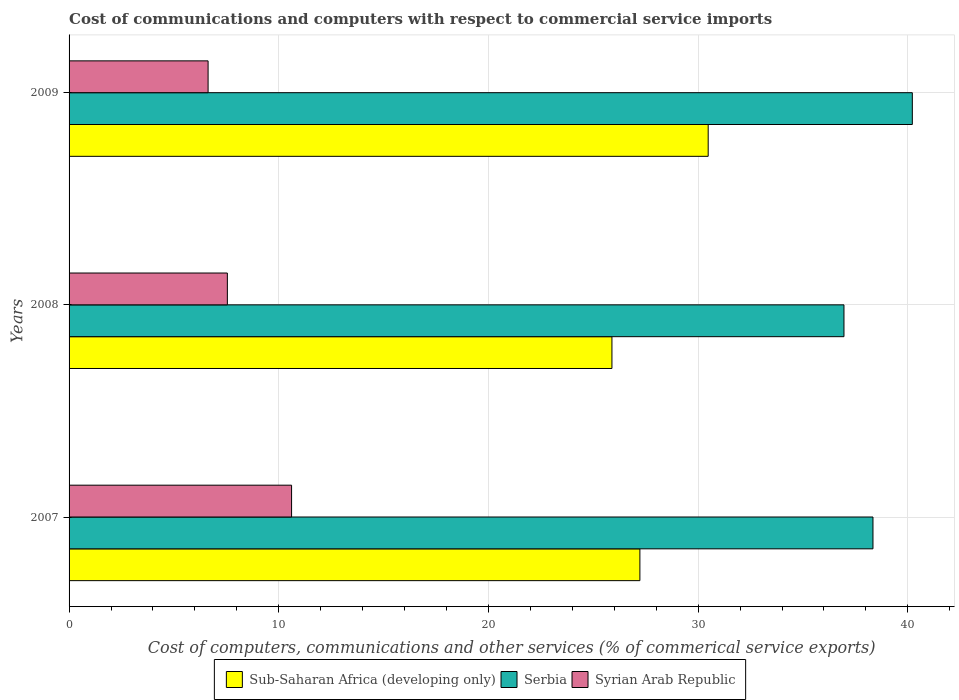How many groups of bars are there?
Provide a succinct answer. 3. How many bars are there on the 1st tick from the top?
Offer a very short reply. 3. How many bars are there on the 3rd tick from the bottom?
Give a very brief answer. 3. In how many cases, is the number of bars for a given year not equal to the number of legend labels?
Offer a terse response. 0. What is the cost of communications and computers in Serbia in 2007?
Your response must be concise. 38.34. Across all years, what is the maximum cost of communications and computers in Syrian Arab Republic?
Make the answer very short. 10.61. Across all years, what is the minimum cost of communications and computers in Serbia?
Offer a terse response. 36.95. In which year was the cost of communications and computers in Sub-Saharan Africa (developing only) maximum?
Your answer should be very brief. 2009. In which year was the cost of communications and computers in Serbia minimum?
Your answer should be very brief. 2008. What is the total cost of communications and computers in Sub-Saharan Africa (developing only) in the graph?
Give a very brief answer. 83.59. What is the difference between the cost of communications and computers in Serbia in 2007 and that in 2009?
Your answer should be very brief. -1.88. What is the difference between the cost of communications and computers in Serbia in 2008 and the cost of communications and computers in Syrian Arab Republic in 2007?
Ensure brevity in your answer.  26.34. What is the average cost of communications and computers in Serbia per year?
Ensure brevity in your answer.  38.5. In the year 2008, what is the difference between the cost of communications and computers in Sub-Saharan Africa (developing only) and cost of communications and computers in Syrian Arab Republic?
Offer a very short reply. 18.34. What is the ratio of the cost of communications and computers in Syrian Arab Republic in 2007 to that in 2008?
Your answer should be compact. 1.41. Is the cost of communications and computers in Syrian Arab Republic in 2007 less than that in 2009?
Give a very brief answer. No. Is the difference between the cost of communications and computers in Sub-Saharan Africa (developing only) in 2007 and 2009 greater than the difference between the cost of communications and computers in Syrian Arab Republic in 2007 and 2009?
Provide a short and direct response. No. What is the difference between the highest and the second highest cost of communications and computers in Syrian Arab Republic?
Give a very brief answer. 3.06. What is the difference between the highest and the lowest cost of communications and computers in Syrian Arab Republic?
Provide a succinct answer. 3.98. In how many years, is the cost of communications and computers in Sub-Saharan Africa (developing only) greater than the average cost of communications and computers in Sub-Saharan Africa (developing only) taken over all years?
Ensure brevity in your answer.  1. Is the sum of the cost of communications and computers in Serbia in 2007 and 2009 greater than the maximum cost of communications and computers in Syrian Arab Republic across all years?
Give a very brief answer. Yes. What does the 2nd bar from the top in 2007 represents?
Your answer should be compact. Serbia. What does the 2nd bar from the bottom in 2009 represents?
Your answer should be very brief. Serbia. Is it the case that in every year, the sum of the cost of communications and computers in Sub-Saharan Africa (developing only) and cost of communications and computers in Serbia is greater than the cost of communications and computers in Syrian Arab Republic?
Ensure brevity in your answer.  Yes. Are all the bars in the graph horizontal?
Offer a very short reply. Yes. How many years are there in the graph?
Provide a short and direct response. 3. What is the difference between two consecutive major ticks on the X-axis?
Provide a short and direct response. 10. Does the graph contain any zero values?
Offer a terse response. No. Where does the legend appear in the graph?
Your answer should be compact. Bottom center. What is the title of the graph?
Ensure brevity in your answer.  Cost of communications and computers with respect to commercial service imports. What is the label or title of the X-axis?
Offer a terse response. Cost of computers, communications and other services (% of commerical service exports). What is the Cost of computers, communications and other services (% of commerical service exports) in Sub-Saharan Africa (developing only) in 2007?
Offer a very short reply. 27.22. What is the Cost of computers, communications and other services (% of commerical service exports) of Serbia in 2007?
Offer a very short reply. 38.34. What is the Cost of computers, communications and other services (% of commerical service exports) in Syrian Arab Republic in 2007?
Provide a short and direct response. 10.61. What is the Cost of computers, communications and other services (% of commerical service exports) of Sub-Saharan Africa (developing only) in 2008?
Your response must be concise. 25.89. What is the Cost of computers, communications and other services (% of commerical service exports) of Serbia in 2008?
Make the answer very short. 36.95. What is the Cost of computers, communications and other services (% of commerical service exports) in Syrian Arab Republic in 2008?
Give a very brief answer. 7.55. What is the Cost of computers, communications and other services (% of commerical service exports) in Sub-Saharan Africa (developing only) in 2009?
Your answer should be compact. 30.48. What is the Cost of computers, communications and other services (% of commerical service exports) in Serbia in 2009?
Your response must be concise. 40.21. What is the Cost of computers, communications and other services (% of commerical service exports) in Syrian Arab Republic in 2009?
Make the answer very short. 6.63. Across all years, what is the maximum Cost of computers, communications and other services (% of commerical service exports) of Sub-Saharan Africa (developing only)?
Provide a short and direct response. 30.48. Across all years, what is the maximum Cost of computers, communications and other services (% of commerical service exports) of Serbia?
Make the answer very short. 40.21. Across all years, what is the maximum Cost of computers, communications and other services (% of commerical service exports) in Syrian Arab Republic?
Offer a terse response. 10.61. Across all years, what is the minimum Cost of computers, communications and other services (% of commerical service exports) of Sub-Saharan Africa (developing only)?
Your answer should be very brief. 25.89. Across all years, what is the minimum Cost of computers, communications and other services (% of commerical service exports) of Serbia?
Ensure brevity in your answer.  36.95. Across all years, what is the minimum Cost of computers, communications and other services (% of commerical service exports) of Syrian Arab Republic?
Make the answer very short. 6.63. What is the total Cost of computers, communications and other services (% of commerical service exports) in Sub-Saharan Africa (developing only) in the graph?
Your answer should be compact. 83.59. What is the total Cost of computers, communications and other services (% of commerical service exports) of Serbia in the graph?
Keep it short and to the point. 115.5. What is the total Cost of computers, communications and other services (% of commerical service exports) of Syrian Arab Republic in the graph?
Offer a very short reply. 24.79. What is the difference between the Cost of computers, communications and other services (% of commerical service exports) in Sub-Saharan Africa (developing only) in 2007 and that in 2008?
Give a very brief answer. 1.33. What is the difference between the Cost of computers, communications and other services (% of commerical service exports) in Serbia in 2007 and that in 2008?
Make the answer very short. 1.38. What is the difference between the Cost of computers, communications and other services (% of commerical service exports) of Syrian Arab Republic in 2007 and that in 2008?
Your response must be concise. 3.06. What is the difference between the Cost of computers, communications and other services (% of commerical service exports) of Sub-Saharan Africa (developing only) in 2007 and that in 2009?
Ensure brevity in your answer.  -3.26. What is the difference between the Cost of computers, communications and other services (% of commerical service exports) in Serbia in 2007 and that in 2009?
Provide a short and direct response. -1.88. What is the difference between the Cost of computers, communications and other services (% of commerical service exports) in Syrian Arab Republic in 2007 and that in 2009?
Offer a very short reply. 3.98. What is the difference between the Cost of computers, communications and other services (% of commerical service exports) in Sub-Saharan Africa (developing only) in 2008 and that in 2009?
Offer a terse response. -4.59. What is the difference between the Cost of computers, communications and other services (% of commerical service exports) of Serbia in 2008 and that in 2009?
Ensure brevity in your answer.  -3.26. What is the difference between the Cost of computers, communications and other services (% of commerical service exports) in Syrian Arab Republic in 2008 and that in 2009?
Keep it short and to the point. 0.92. What is the difference between the Cost of computers, communications and other services (% of commerical service exports) of Sub-Saharan Africa (developing only) in 2007 and the Cost of computers, communications and other services (% of commerical service exports) of Serbia in 2008?
Keep it short and to the point. -9.73. What is the difference between the Cost of computers, communications and other services (% of commerical service exports) of Sub-Saharan Africa (developing only) in 2007 and the Cost of computers, communications and other services (% of commerical service exports) of Syrian Arab Republic in 2008?
Ensure brevity in your answer.  19.67. What is the difference between the Cost of computers, communications and other services (% of commerical service exports) in Serbia in 2007 and the Cost of computers, communications and other services (% of commerical service exports) in Syrian Arab Republic in 2008?
Ensure brevity in your answer.  30.79. What is the difference between the Cost of computers, communications and other services (% of commerical service exports) in Sub-Saharan Africa (developing only) in 2007 and the Cost of computers, communications and other services (% of commerical service exports) in Serbia in 2009?
Keep it short and to the point. -12.99. What is the difference between the Cost of computers, communications and other services (% of commerical service exports) in Sub-Saharan Africa (developing only) in 2007 and the Cost of computers, communications and other services (% of commerical service exports) in Syrian Arab Republic in 2009?
Keep it short and to the point. 20.59. What is the difference between the Cost of computers, communications and other services (% of commerical service exports) in Serbia in 2007 and the Cost of computers, communications and other services (% of commerical service exports) in Syrian Arab Republic in 2009?
Offer a terse response. 31.71. What is the difference between the Cost of computers, communications and other services (% of commerical service exports) of Sub-Saharan Africa (developing only) in 2008 and the Cost of computers, communications and other services (% of commerical service exports) of Serbia in 2009?
Ensure brevity in your answer.  -14.33. What is the difference between the Cost of computers, communications and other services (% of commerical service exports) in Sub-Saharan Africa (developing only) in 2008 and the Cost of computers, communications and other services (% of commerical service exports) in Syrian Arab Republic in 2009?
Keep it short and to the point. 19.26. What is the difference between the Cost of computers, communications and other services (% of commerical service exports) of Serbia in 2008 and the Cost of computers, communications and other services (% of commerical service exports) of Syrian Arab Republic in 2009?
Your answer should be very brief. 30.32. What is the average Cost of computers, communications and other services (% of commerical service exports) of Sub-Saharan Africa (developing only) per year?
Offer a terse response. 27.86. What is the average Cost of computers, communications and other services (% of commerical service exports) in Serbia per year?
Provide a short and direct response. 38.5. What is the average Cost of computers, communications and other services (% of commerical service exports) in Syrian Arab Republic per year?
Make the answer very short. 8.26. In the year 2007, what is the difference between the Cost of computers, communications and other services (% of commerical service exports) of Sub-Saharan Africa (developing only) and Cost of computers, communications and other services (% of commerical service exports) of Serbia?
Your answer should be very brief. -11.12. In the year 2007, what is the difference between the Cost of computers, communications and other services (% of commerical service exports) of Sub-Saharan Africa (developing only) and Cost of computers, communications and other services (% of commerical service exports) of Syrian Arab Republic?
Keep it short and to the point. 16.61. In the year 2007, what is the difference between the Cost of computers, communications and other services (% of commerical service exports) of Serbia and Cost of computers, communications and other services (% of commerical service exports) of Syrian Arab Republic?
Offer a terse response. 27.73. In the year 2008, what is the difference between the Cost of computers, communications and other services (% of commerical service exports) in Sub-Saharan Africa (developing only) and Cost of computers, communications and other services (% of commerical service exports) in Serbia?
Offer a very short reply. -11.07. In the year 2008, what is the difference between the Cost of computers, communications and other services (% of commerical service exports) in Sub-Saharan Africa (developing only) and Cost of computers, communications and other services (% of commerical service exports) in Syrian Arab Republic?
Provide a succinct answer. 18.34. In the year 2008, what is the difference between the Cost of computers, communications and other services (% of commerical service exports) in Serbia and Cost of computers, communications and other services (% of commerical service exports) in Syrian Arab Republic?
Give a very brief answer. 29.4. In the year 2009, what is the difference between the Cost of computers, communications and other services (% of commerical service exports) in Sub-Saharan Africa (developing only) and Cost of computers, communications and other services (% of commerical service exports) in Serbia?
Offer a very short reply. -9.73. In the year 2009, what is the difference between the Cost of computers, communications and other services (% of commerical service exports) of Sub-Saharan Africa (developing only) and Cost of computers, communications and other services (% of commerical service exports) of Syrian Arab Republic?
Offer a very short reply. 23.85. In the year 2009, what is the difference between the Cost of computers, communications and other services (% of commerical service exports) in Serbia and Cost of computers, communications and other services (% of commerical service exports) in Syrian Arab Republic?
Offer a very short reply. 33.58. What is the ratio of the Cost of computers, communications and other services (% of commerical service exports) of Sub-Saharan Africa (developing only) in 2007 to that in 2008?
Your answer should be compact. 1.05. What is the ratio of the Cost of computers, communications and other services (% of commerical service exports) in Serbia in 2007 to that in 2008?
Provide a succinct answer. 1.04. What is the ratio of the Cost of computers, communications and other services (% of commerical service exports) of Syrian Arab Republic in 2007 to that in 2008?
Offer a very short reply. 1.41. What is the ratio of the Cost of computers, communications and other services (% of commerical service exports) in Sub-Saharan Africa (developing only) in 2007 to that in 2009?
Provide a short and direct response. 0.89. What is the ratio of the Cost of computers, communications and other services (% of commerical service exports) of Serbia in 2007 to that in 2009?
Ensure brevity in your answer.  0.95. What is the ratio of the Cost of computers, communications and other services (% of commerical service exports) in Syrian Arab Republic in 2007 to that in 2009?
Ensure brevity in your answer.  1.6. What is the ratio of the Cost of computers, communications and other services (% of commerical service exports) of Sub-Saharan Africa (developing only) in 2008 to that in 2009?
Your answer should be very brief. 0.85. What is the ratio of the Cost of computers, communications and other services (% of commerical service exports) in Serbia in 2008 to that in 2009?
Give a very brief answer. 0.92. What is the ratio of the Cost of computers, communications and other services (% of commerical service exports) of Syrian Arab Republic in 2008 to that in 2009?
Offer a very short reply. 1.14. What is the difference between the highest and the second highest Cost of computers, communications and other services (% of commerical service exports) in Sub-Saharan Africa (developing only)?
Ensure brevity in your answer.  3.26. What is the difference between the highest and the second highest Cost of computers, communications and other services (% of commerical service exports) of Serbia?
Keep it short and to the point. 1.88. What is the difference between the highest and the second highest Cost of computers, communications and other services (% of commerical service exports) in Syrian Arab Republic?
Keep it short and to the point. 3.06. What is the difference between the highest and the lowest Cost of computers, communications and other services (% of commerical service exports) of Sub-Saharan Africa (developing only)?
Keep it short and to the point. 4.59. What is the difference between the highest and the lowest Cost of computers, communications and other services (% of commerical service exports) of Serbia?
Provide a succinct answer. 3.26. What is the difference between the highest and the lowest Cost of computers, communications and other services (% of commerical service exports) in Syrian Arab Republic?
Your answer should be very brief. 3.98. 